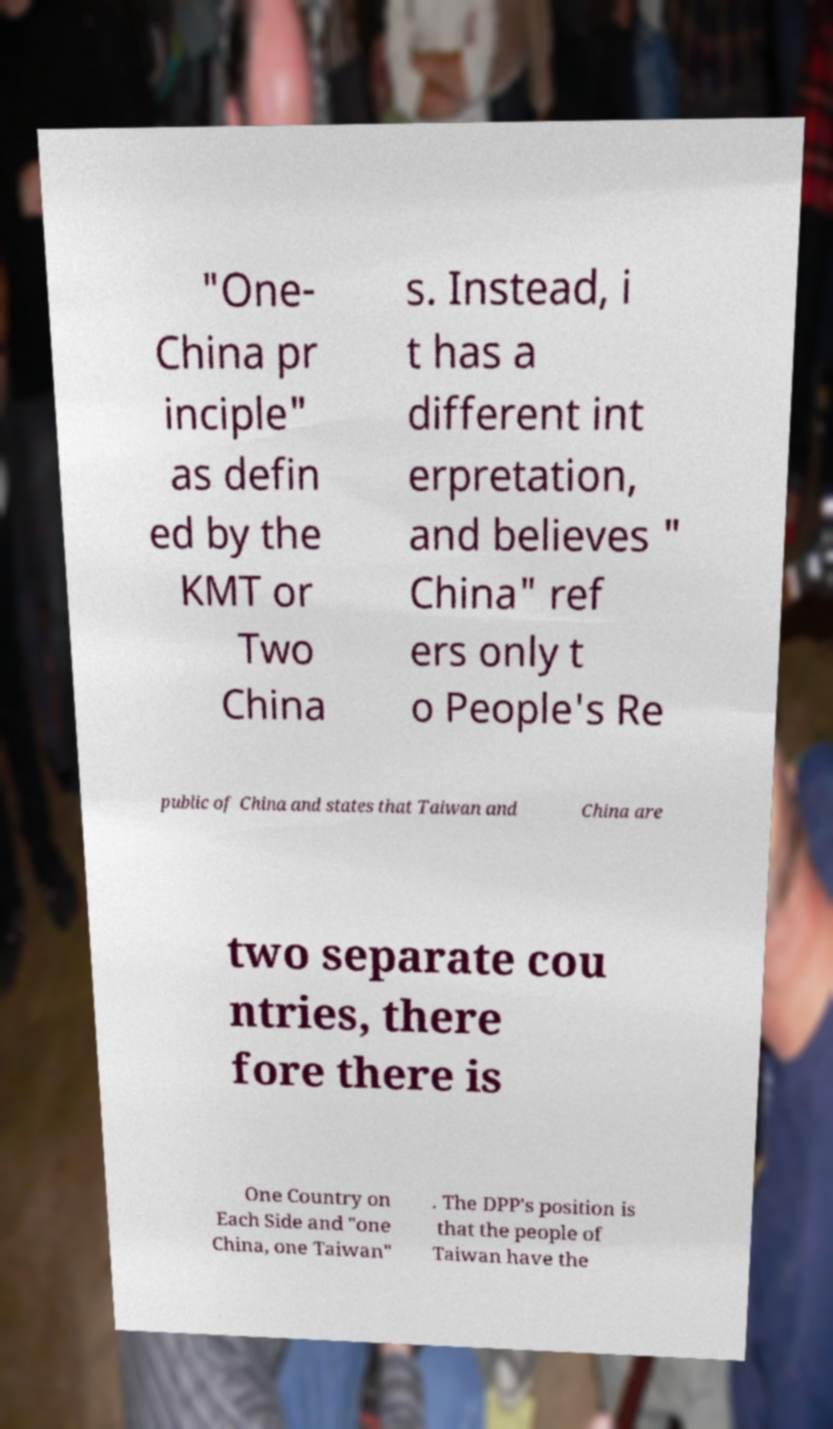What messages or text are displayed in this image? I need them in a readable, typed format. "One- China pr inciple" as defin ed by the KMT or Two China s. Instead, i t has a different int erpretation, and believes " China" ref ers only t o People's Re public of China and states that Taiwan and China are two separate cou ntries, there fore there is One Country on Each Side and "one China, one Taiwan" . The DPP's position is that the people of Taiwan have the 